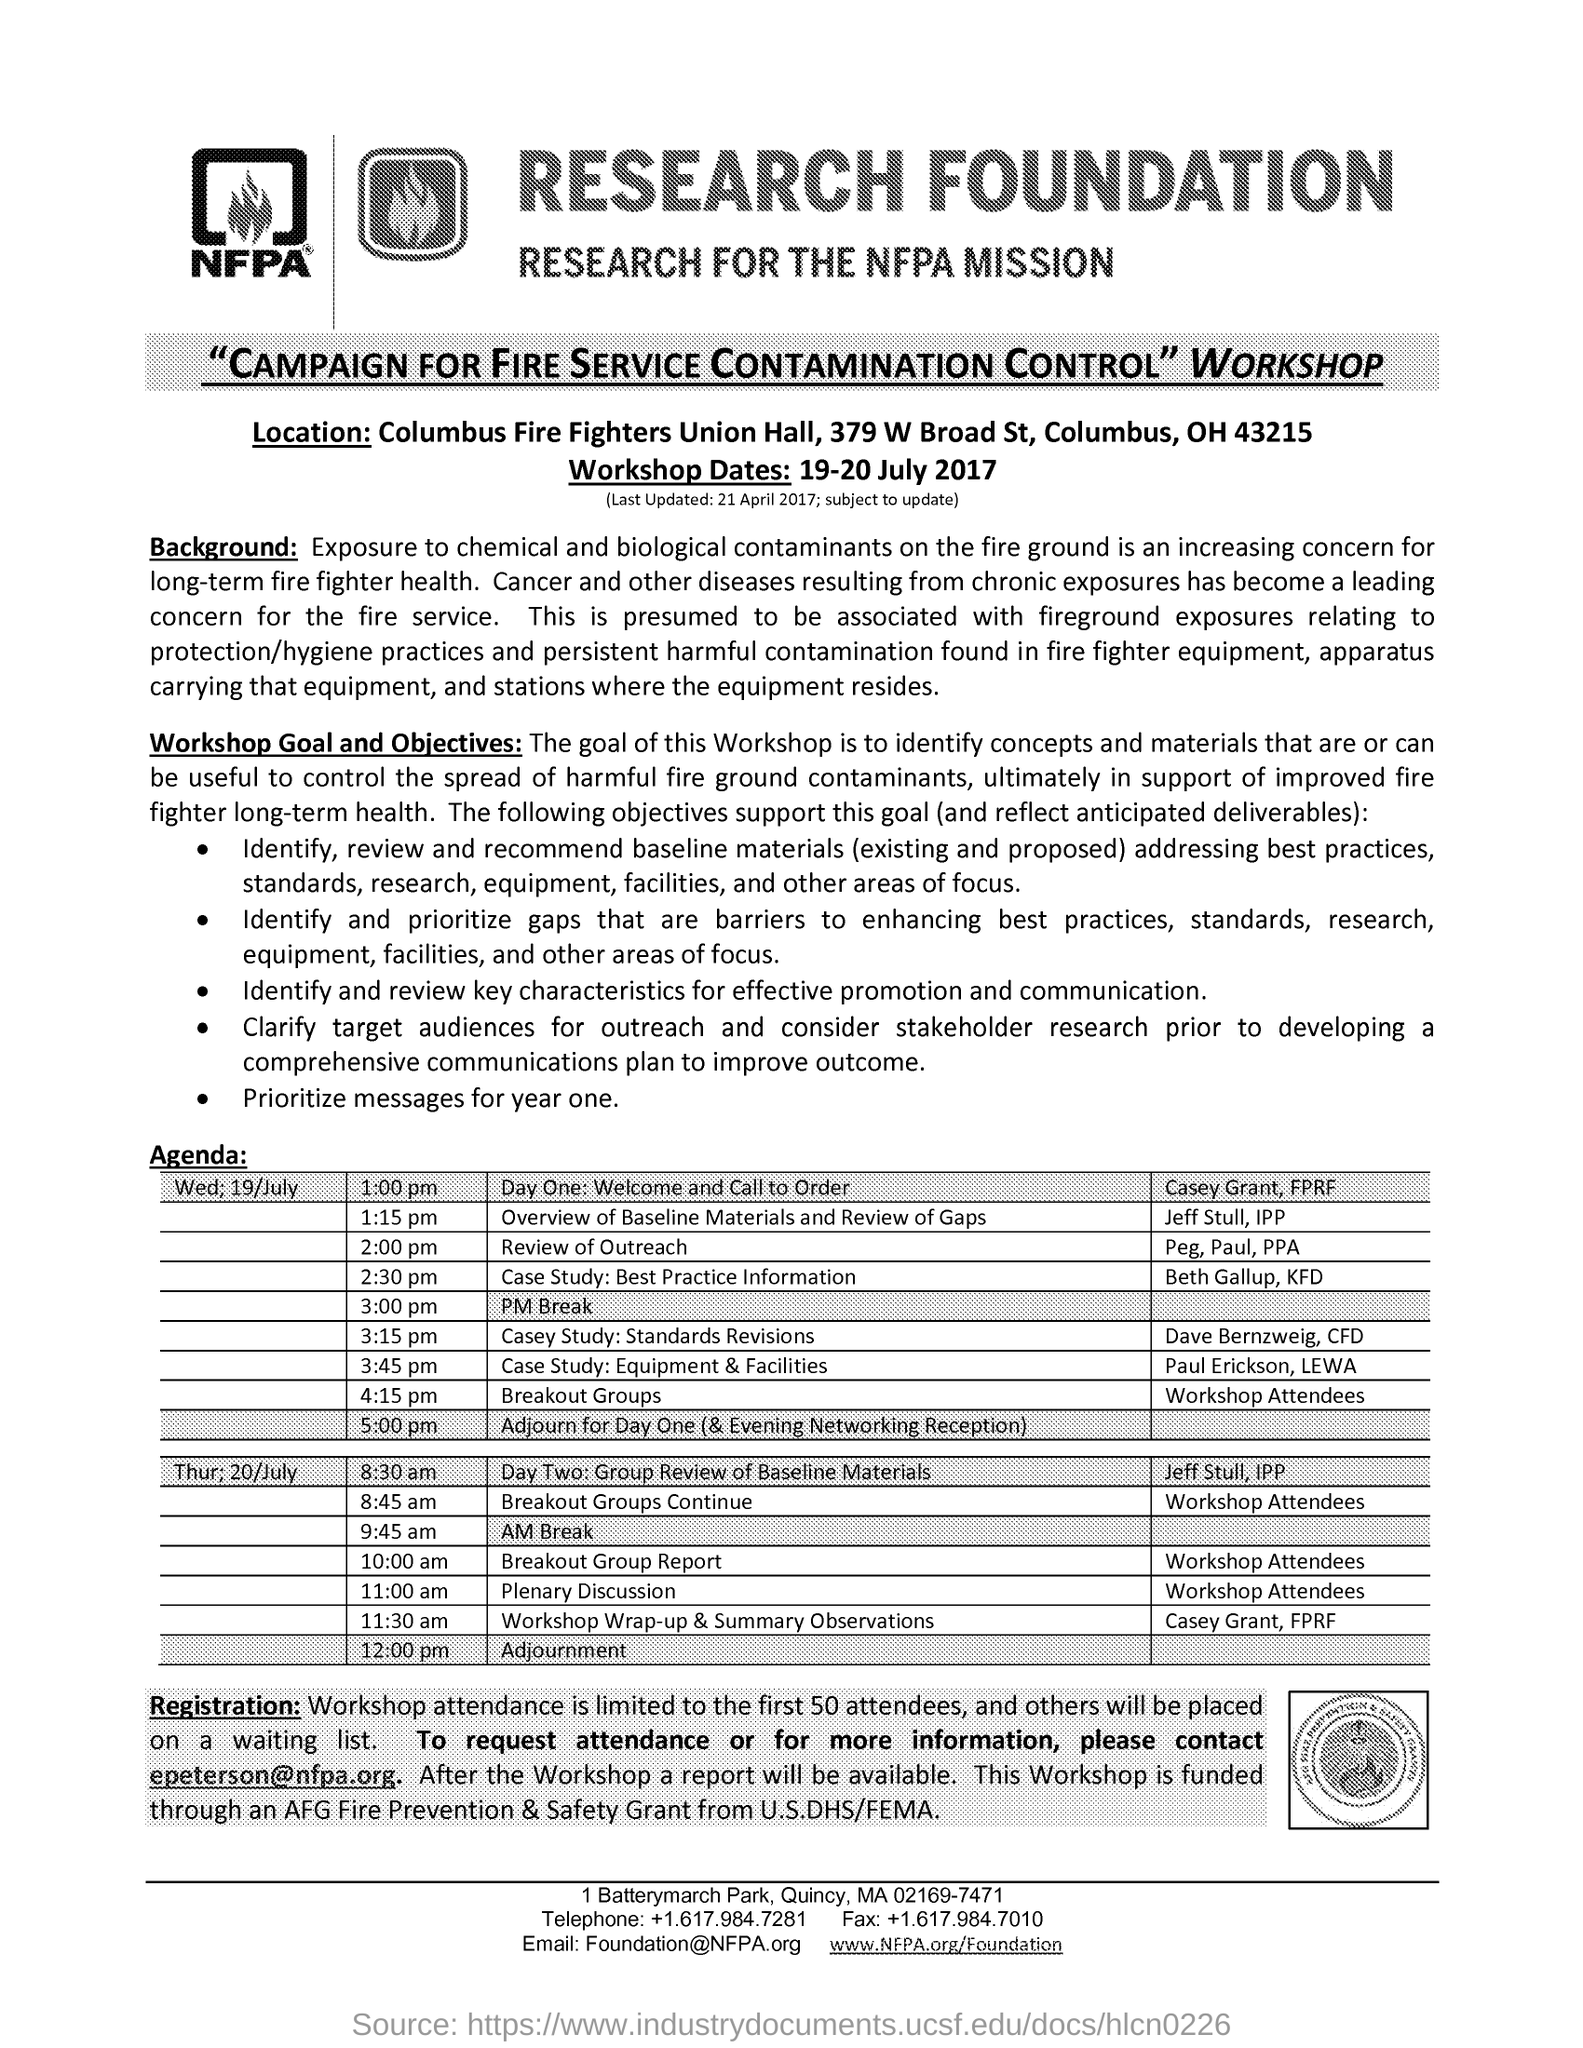Indicate a few pertinent items in this graphic. The goal of this workshop is to identify concepts and materials that can assist in controlling the spread of harmful fire ground contaminants, with the ultimate aim of promoting the long-term health of firefighters. The workshop will take place on July 19-20, 2017. The limit of Workshop attendance is 50 attendees 